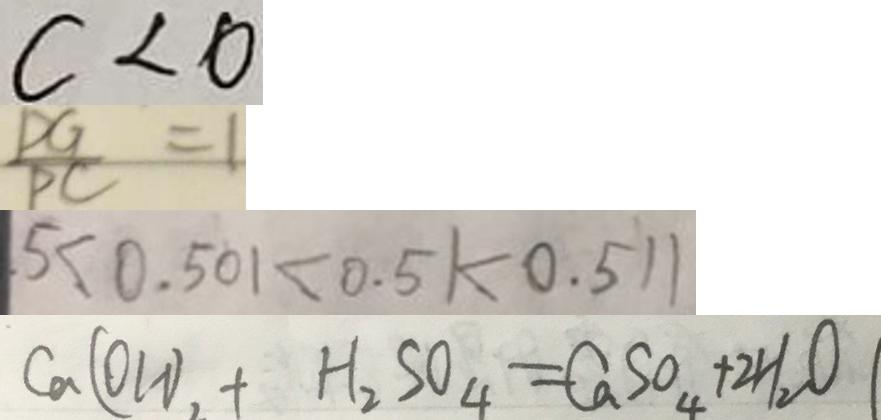<formula> <loc_0><loc_0><loc_500><loc_500>c < 0 
 \frac { D G } { P C } = 1 
 . 5 < 0 . 5 0 1 < 0 . 5 1 < 0 . 5 1 1 
 C a ( O H ) _ { 2 } + H _ { 2 } S O _ { 4 } = C a S O _ { 4 } + 2 H _ { 2 } O</formula> 